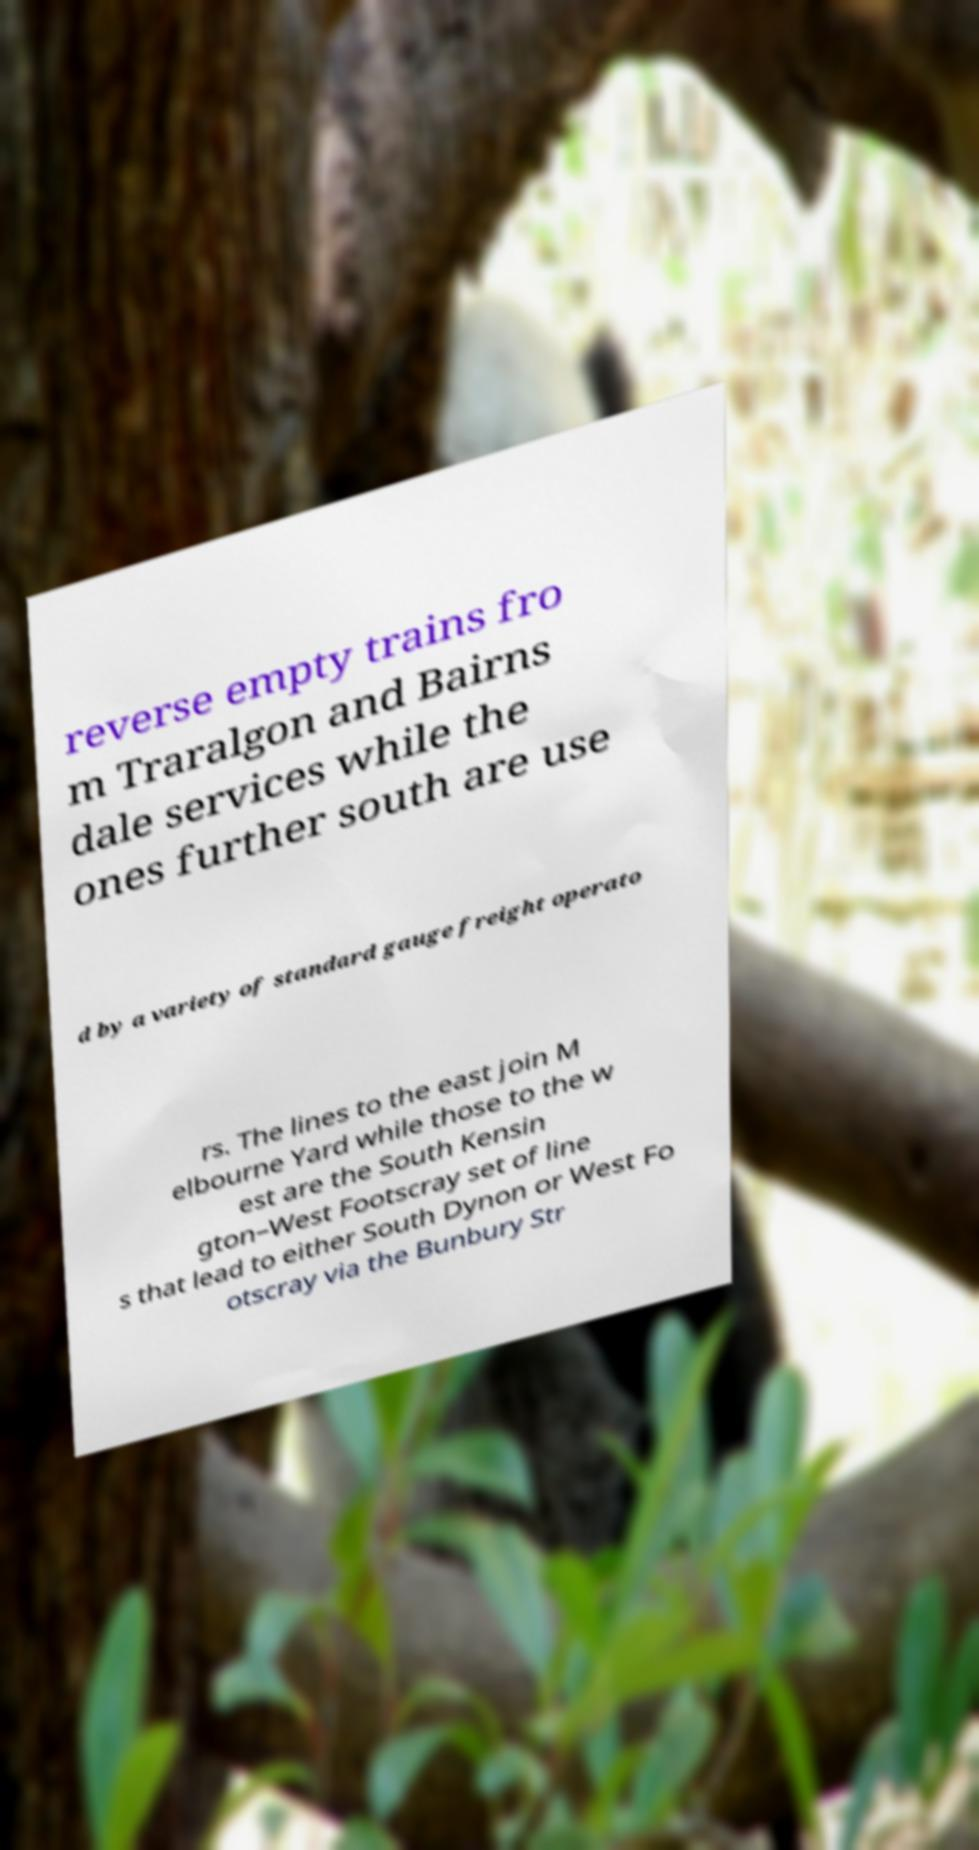There's text embedded in this image that I need extracted. Can you transcribe it verbatim? reverse empty trains fro m Traralgon and Bairns dale services while the ones further south are use d by a variety of standard gauge freight operato rs. The lines to the east join M elbourne Yard while those to the w est are the South Kensin gton–West Footscray set of line s that lead to either South Dynon or West Fo otscray via the Bunbury Str 